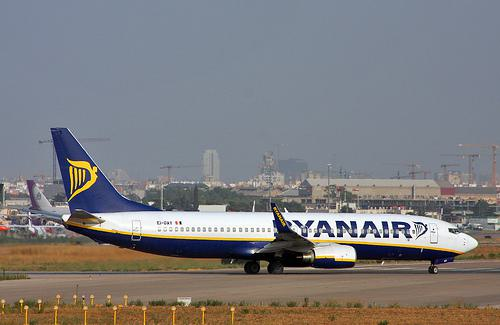How many aeroplanes would there be in the image if two aeroplanes were deleted from the scene? The image shows only one aeroplane, so if two were removed from this scene, theoretically, there would be negative one aeroplanes, which is impossible in reality. Essentially, the count of aeroplanes would remain at zero, as you cannot have less than zero physical objects. 